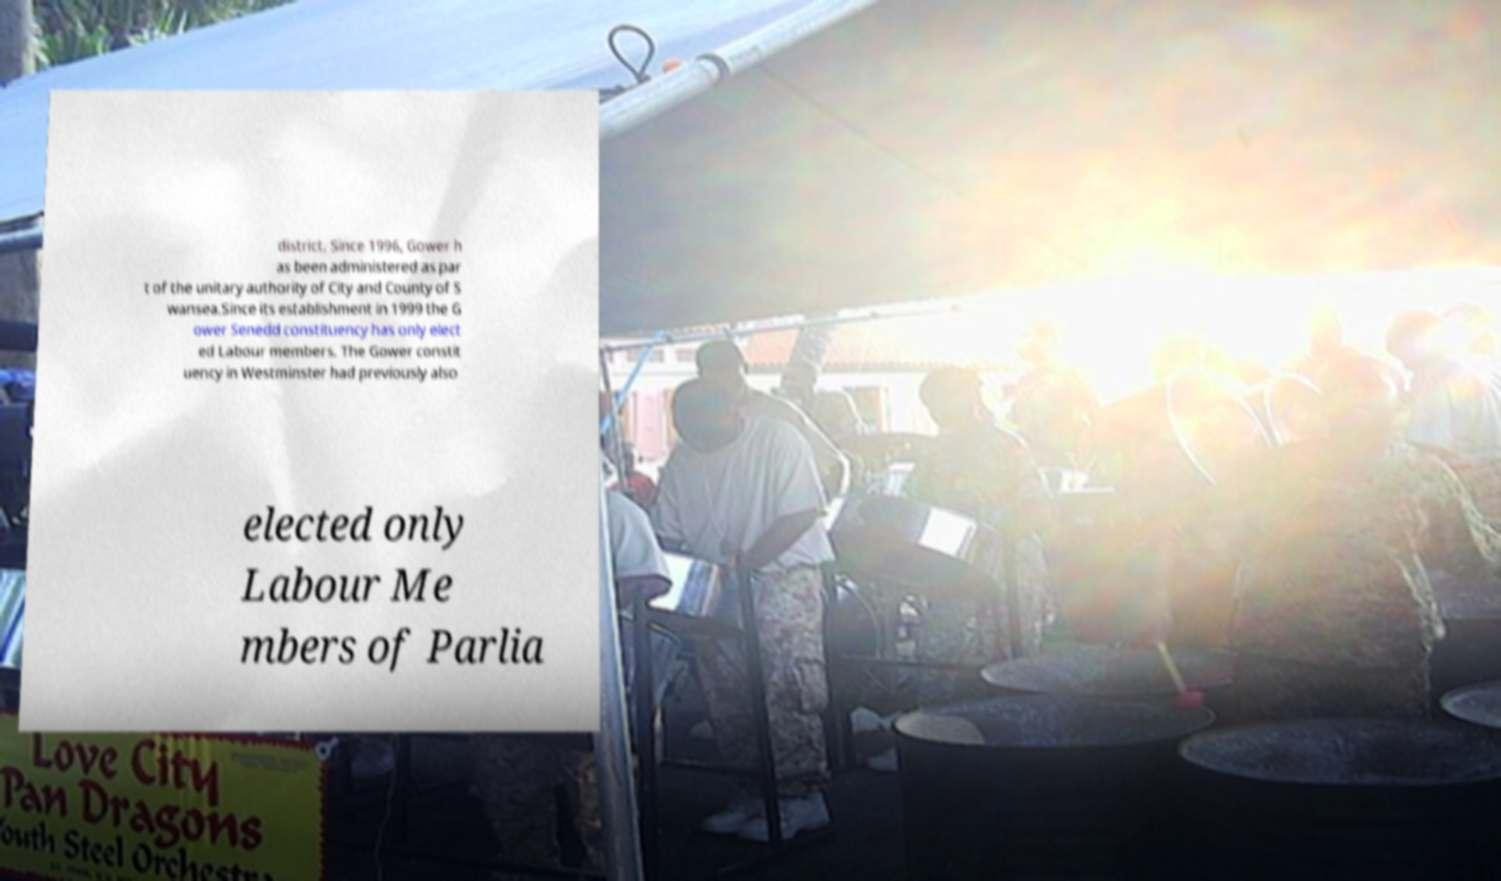For documentation purposes, I need the text within this image transcribed. Could you provide that? district. Since 1996, Gower h as been administered as par t of the unitary authority of City and County of S wansea.Since its establishment in 1999 the G ower Senedd constituency has only elect ed Labour members. The Gower constit uency in Westminster had previously also elected only Labour Me mbers of Parlia 